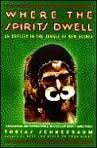Who wrote this book?
Answer the question using a single word or phrase. Tobias Schneebaum What is the title of this book? Where the Spirits Dwell: An Odyssey in the New Guinea Jungle What type of book is this? Travel Is this book related to Travel? Yes Is this book related to Politics & Social Sciences? No 